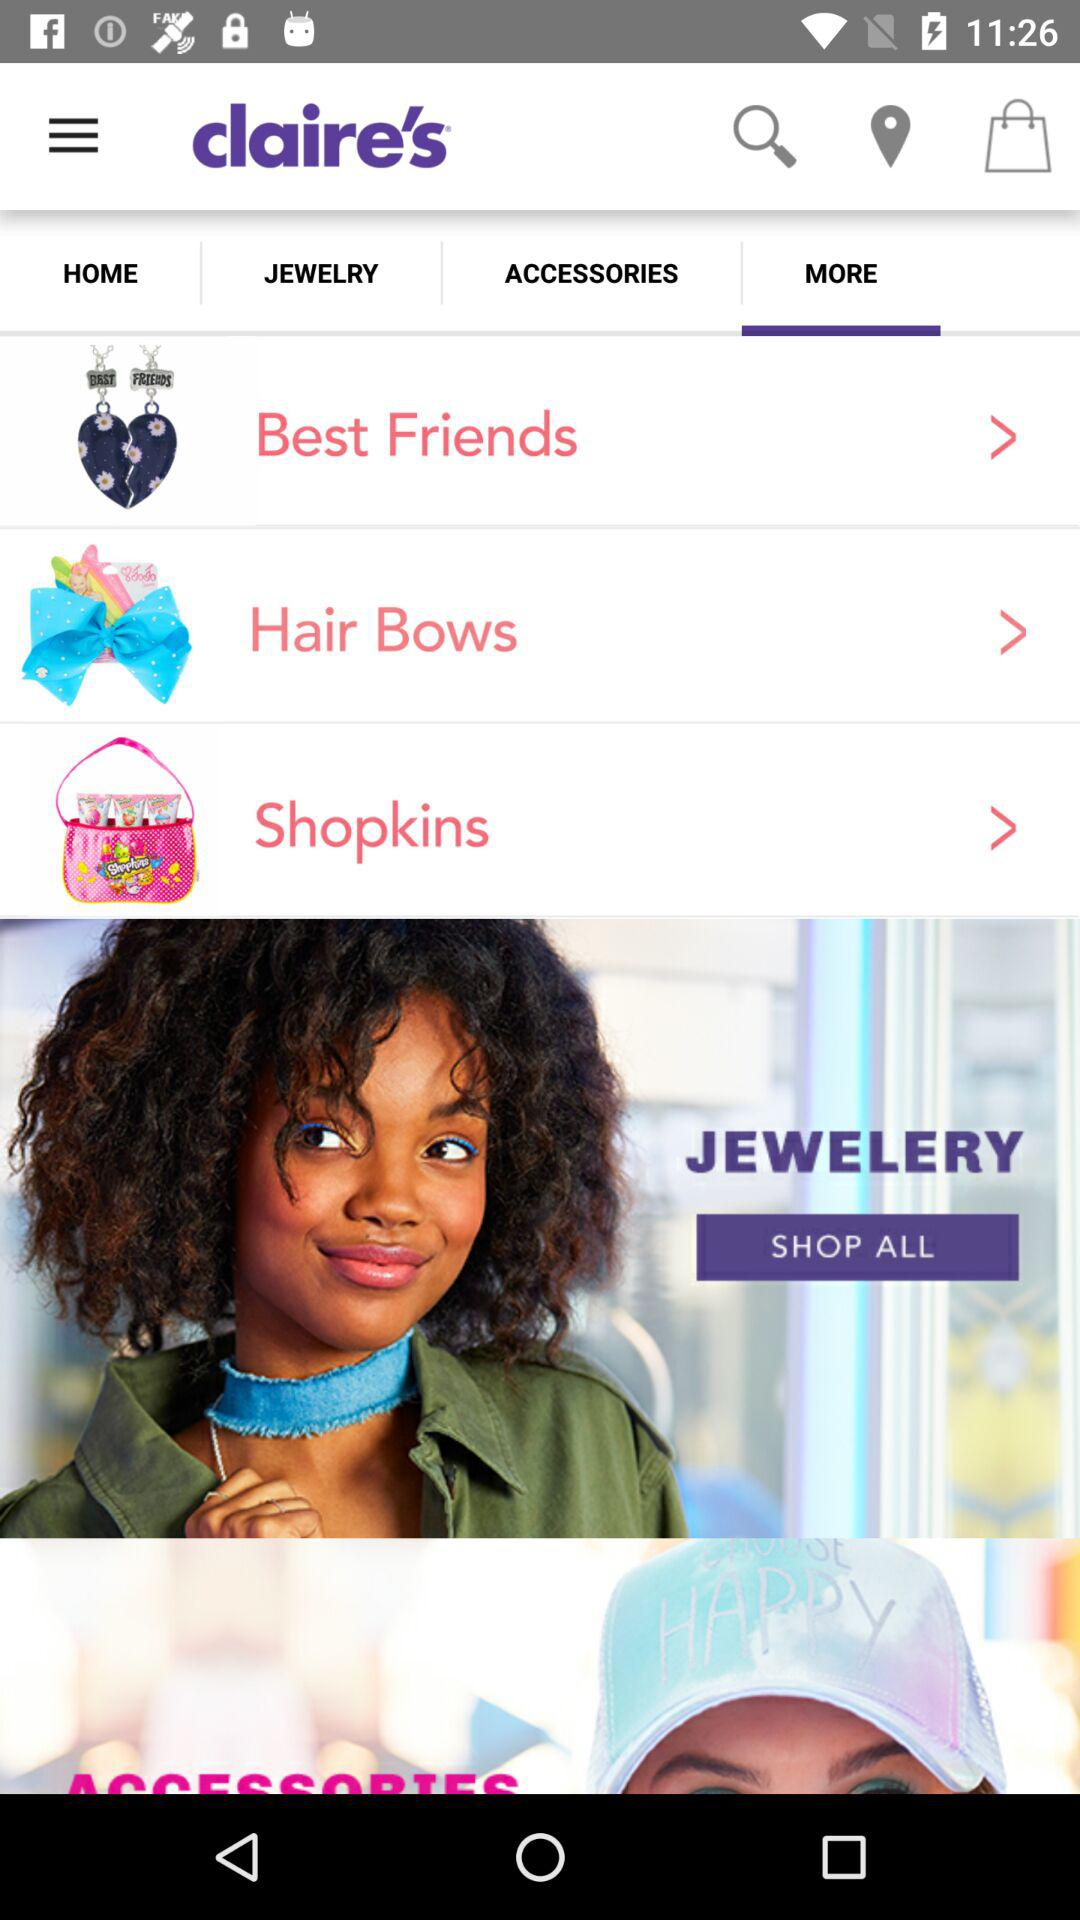Is "Best Friends" selected?
When the provided information is insufficient, respond with <no answer>. <no answer> 